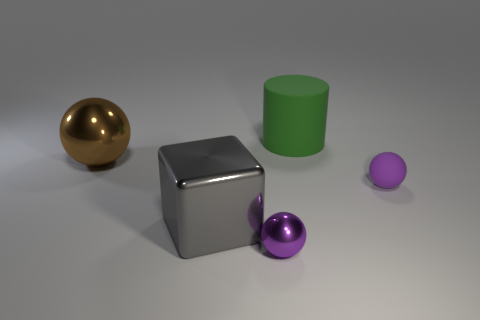There is a gray block; are there any purple things behind it?
Ensure brevity in your answer.  Yes. Is there a tiny thing that has the same color as the matte sphere?
Your response must be concise. Yes. How many tiny objects are either purple balls or brown rubber cubes?
Give a very brief answer. 2. Do the purple object that is to the right of the green matte thing and the brown sphere have the same material?
Make the answer very short. No. What shape is the big object behind the ball to the left of the purple object that is to the left of the small rubber thing?
Provide a succinct answer. Cylinder. What number of red objects are large spheres or rubber blocks?
Provide a short and direct response. 0. Are there an equal number of blocks that are behind the large metallic block and large things in front of the large green object?
Ensure brevity in your answer.  No. Is the shape of the large metal object right of the brown ball the same as the purple thing to the left of the large matte cylinder?
Ensure brevity in your answer.  No. Are there any other things that are the same shape as the brown object?
Provide a short and direct response. Yes. The tiny purple thing that is the same material as the brown thing is what shape?
Keep it short and to the point. Sphere. 